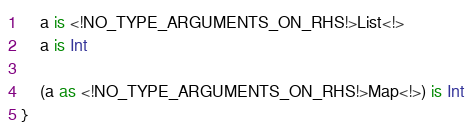Convert code to text. <code><loc_0><loc_0><loc_500><loc_500><_Kotlin_>    a is <!NO_TYPE_ARGUMENTS_ON_RHS!>List<!>
    a is Int

    (a as <!NO_TYPE_ARGUMENTS_ON_RHS!>Map<!>) is Int
}
</code> 